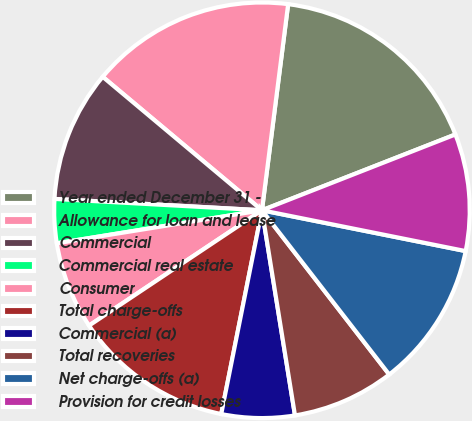Convert chart. <chart><loc_0><loc_0><loc_500><loc_500><pie_chart><fcel>Year ended December 31 -<fcel>Allowance for loan and lease<fcel>Commercial<fcel>Commercial real estate<fcel>Consumer<fcel>Total charge-offs<fcel>Commercial (a)<fcel>Total recoveries<fcel>Net charge-offs (a)<fcel>Provision for credit losses<nl><fcel>17.04%<fcel>15.91%<fcel>10.23%<fcel>3.41%<fcel>6.82%<fcel>12.5%<fcel>5.68%<fcel>7.95%<fcel>11.36%<fcel>9.09%<nl></chart> 